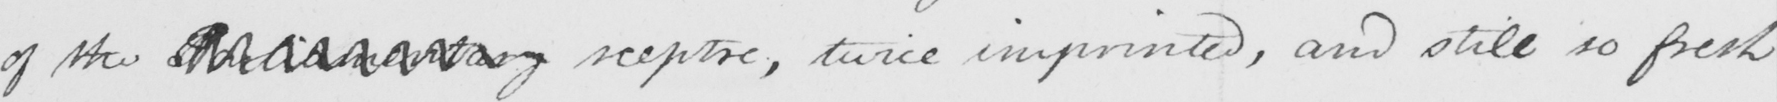Can you tell me what this handwritten text says? of the Parliamentary sceptre , twice imprinted , and still so fresh 